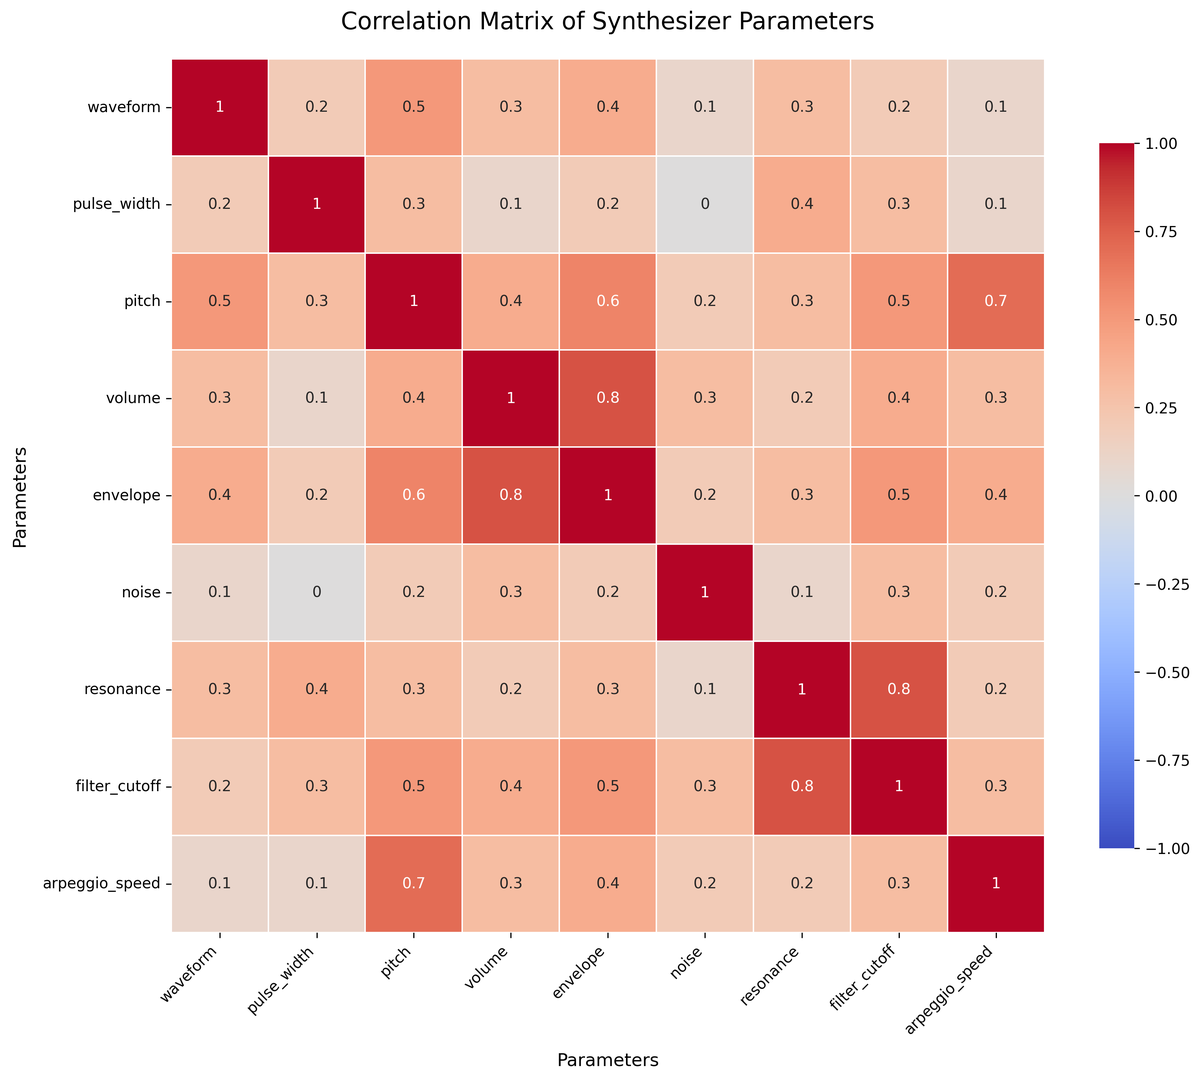Which parameter has the highest correlation with volume? By looking at the heatmap, the highest value in the volume row/column indicates the strongest positive relationship. The value is located at the intersection with the envelope parameter, showing a correlation coefficient of 0.8.
Answer: envelope What is the correlation between pitch and filter_cutoff? Based on the heatmap, find the cell where the pitch row intersects with the filter_cutoff column. The value in this cell represents the correlation coefficient.
Answer: 0.5 Which parameter shows the lowest correlation with noise? Look for the smallest value in the noise row/column of the heatmap. The smallest value is 0.0, corresponding to the pulse_width parameter.
Answer: pulse_width How does the correlation between arpeggio_speed and envelope compare to that between pitch and volume? First, find the correlation values for arpeggio_speed with envelope and pitch with volume by checking the respective cells in the heatmap. Arpeggio_speed and envelope have a correlation of 0.4, while pitch and volume have a correlation of 0.4.
Answer: Equal Which two parameters have the highest correlation overall? Examine the heatmap to identify the cell with the highest correlation value, excluding the diagonal (which is always 1.0). The highest non-diagonal value is 0.8, occurring between resonance and filter_cutoff.
Answer: resonance and filter_cutoff Are there any negative correlations shown in the heatmap? Check the color intensities and corresponding annotation values in the heatmap. All values range from 0.0 to 1.0, indicating no negative correlations.
Answer: No What is the average correlation coefficient between the envelope and the following parameters: pitch, volume, filter_cutoff? Locate the correlation coefficients for envelope with pitch (0.6), volume (0.8), and filter_cutoff (0.5) in the heatmap. Calculate the average: (0.6 + 0.8 + 0.5) / 3 = 1.9 / 3.
Answer: 0.63 